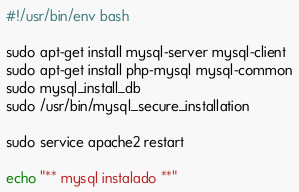<code> <loc_0><loc_0><loc_500><loc_500><_Bash_>#!/usr/bin/env bash

sudo apt-get install mysql-server mysql-client
sudo apt-get install php-mysql mysql-common
sudo mysql_install_db
sudo /usr/bin/mysql_secure_installation

sudo service apache2 restart

echo "** mysql instalado **"
</code> 